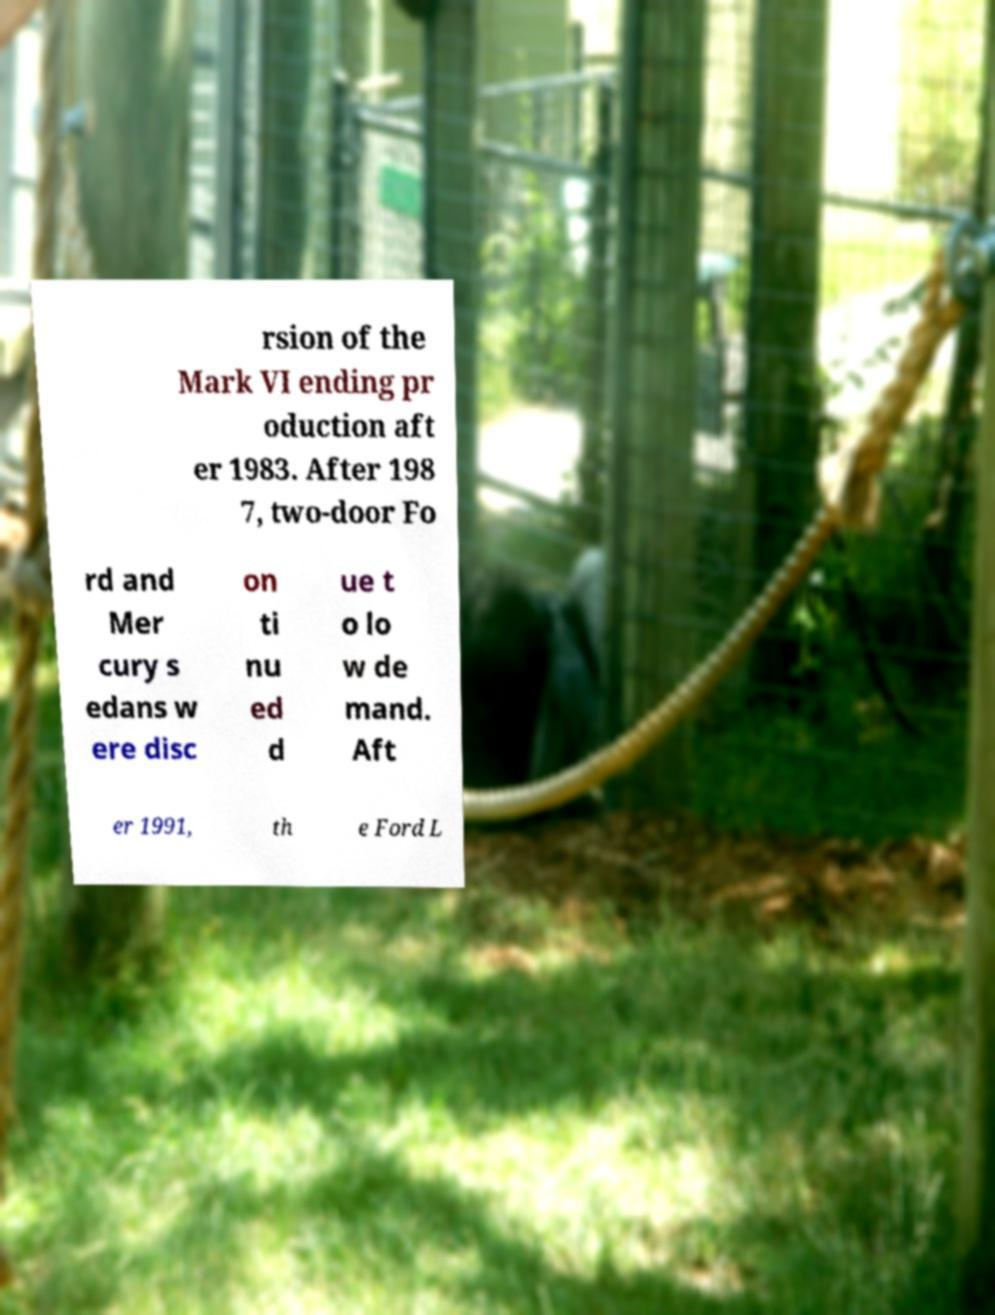Could you assist in decoding the text presented in this image and type it out clearly? rsion of the Mark VI ending pr oduction aft er 1983. After 198 7, two-door Fo rd and Mer cury s edans w ere disc on ti nu ed d ue t o lo w de mand. Aft er 1991, th e Ford L 